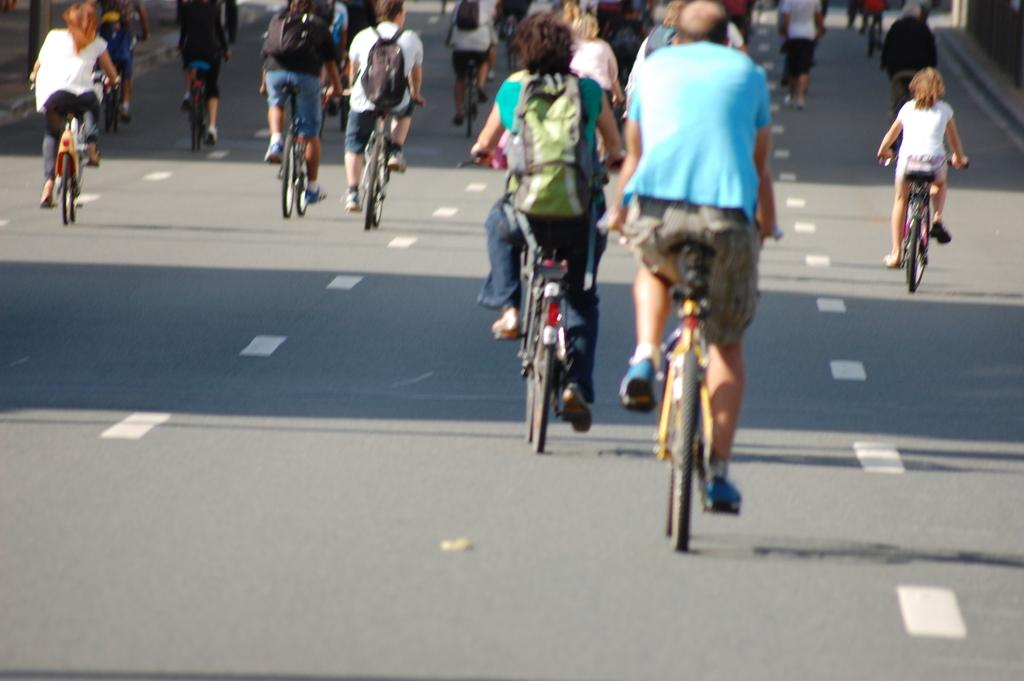What are the people in the image doing? The people in the image are riding bicycles. What are some of the people carrying while riding bicycles? Some of the people riding bicycles are wearing backpacks. What is happening on the right side of the image? There is a person walking on the right side of the image. What type of observation can be made about the feeling of the rod in the image? There is no rod present in the image, so it is not possible to make any observations about its feeling. 